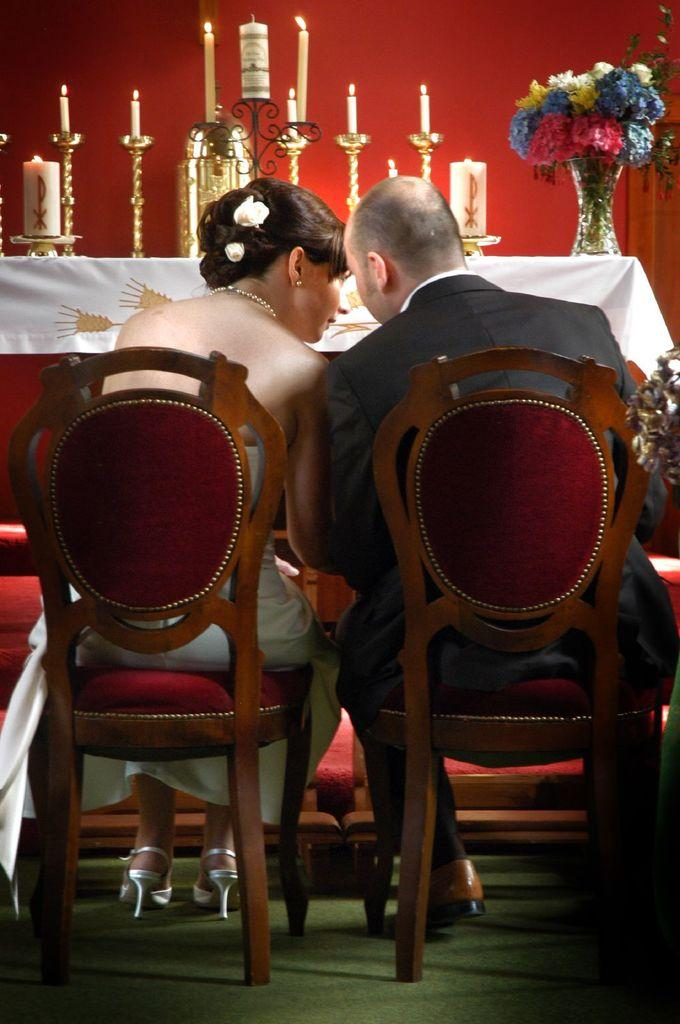Who is present in the image? There is a couple in the image. What are the couple doing in the image? The couple is sitting on chairs. What can be seen in the background of the image? In the background, there are candles on a table and a flower flask on the table. How many baseball sticks are visible in the image? There are no baseball sticks present in the image. Why is the couple crying in the image? The couple is not crying in the image; there is no indication of any emotional state. 